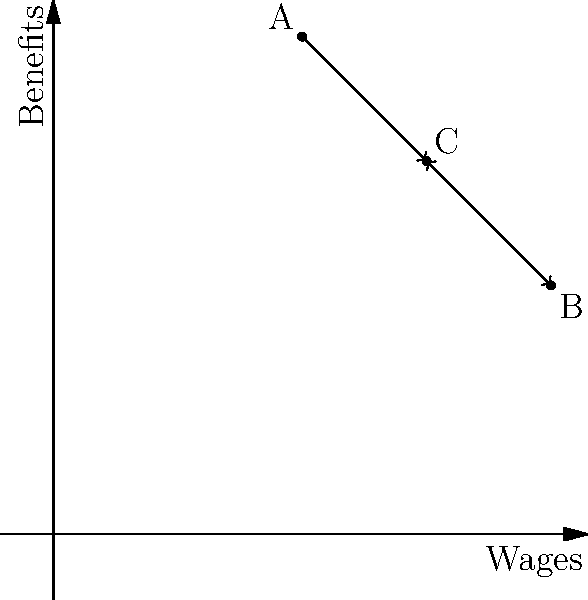In a union election, three candidates (A, B, and C) are represented by vectors in a 2D space, where the x-axis represents their stance on wages and the y-axis represents their stance on benefits. Given the diagram, which candidate is likely to receive the most support from union members who prioritize a balanced approach to both wages and benefits? To determine which candidate is likely to receive the most support from union members who prioritize a balanced approach to both wages and benefits, we need to analyze the position of each candidate in the given 2D space:

1. Candidate A: Located at (2,4), this candidate strongly favors benefits over wages.
2. Candidate B: Located at (4,2), this candidate strongly favors wages over benefits.
3. Candidate C: Located at (3,3), this candidate has a balanced approach to both wages and benefits.

Union members who prioritize a balanced approach would prefer a candidate whose position is closest to the line $y = x$, which represents an equal emphasis on both wages and benefits.

To determine which candidate is closest to this balanced approach, we can:

1. Visualize the line $y = x$ (although not drawn, it would pass through points like (0,0), (1,1), (2,2), etc.).
2. Observe that Candidate C is positioned exactly on this line at (3,3).
3. Note that both Candidate A and Candidate B are positioned farther from this line, representing more extreme positions.

Therefore, Candidate C, with their balanced stance on both wages and benefits, is most likely to receive support from union members seeking a balanced approach.
Answer: Candidate C 